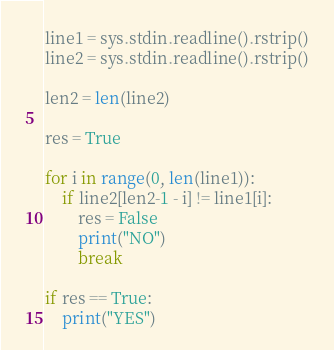Convert code to text. <code><loc_0><loc_0><loc_500><loc_500><_Python_>line1 = sys.stdin.readline().rstrip()
line2 = sys.stdin.readline().rstrip()

len2 = len(line2)

res = True

for i in range(0, len(line1)):
    if line2[len2-1 - i] != line1[i]:
        res = False
        print("NO")
        break

if res == True:
    print("YES")</code> 